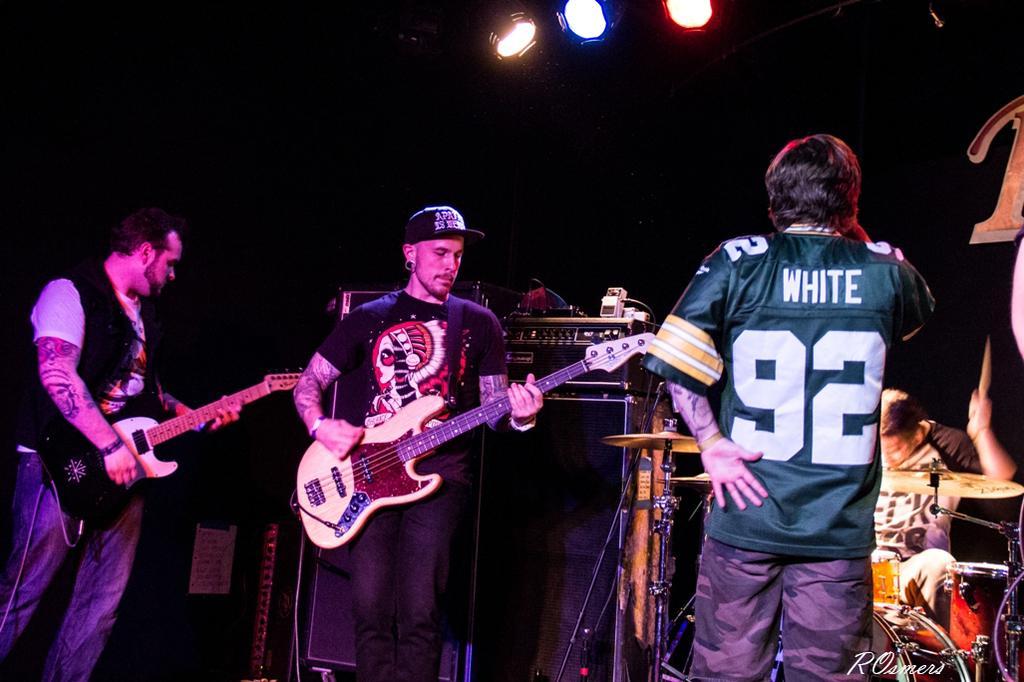Describe this image in one or two sentences. These 2 persons are standing and playing a guitar. This is speaker. This man is sitting and playing these musical instruments. On top there are focusing lights. Front this man is standing and wore shirt. 